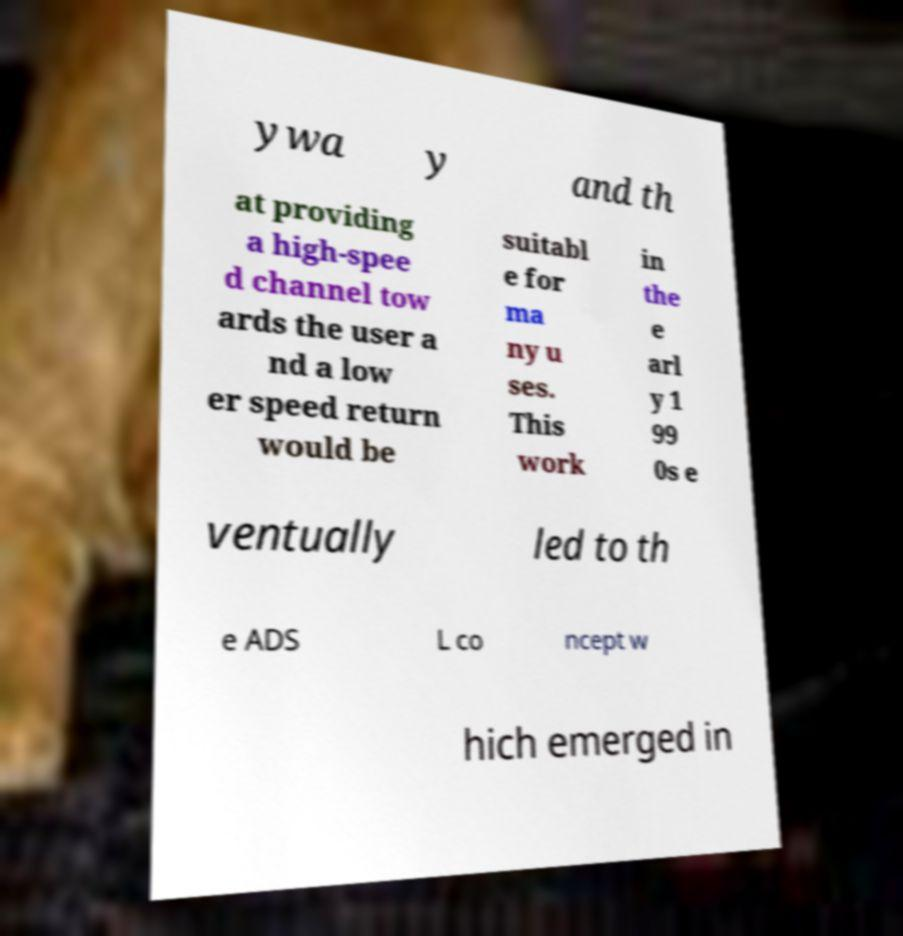For documentation purposes, I need the text within this image transcribed. Could you provide that? ywa y and th at providing a high-spee d channel tow ards the user a nd a low er speed return would be suitabl e for ma ny u ses. This work in the e arl y 1 99 0s e ventually led to th e ADS L co ncept w hich emerged in 